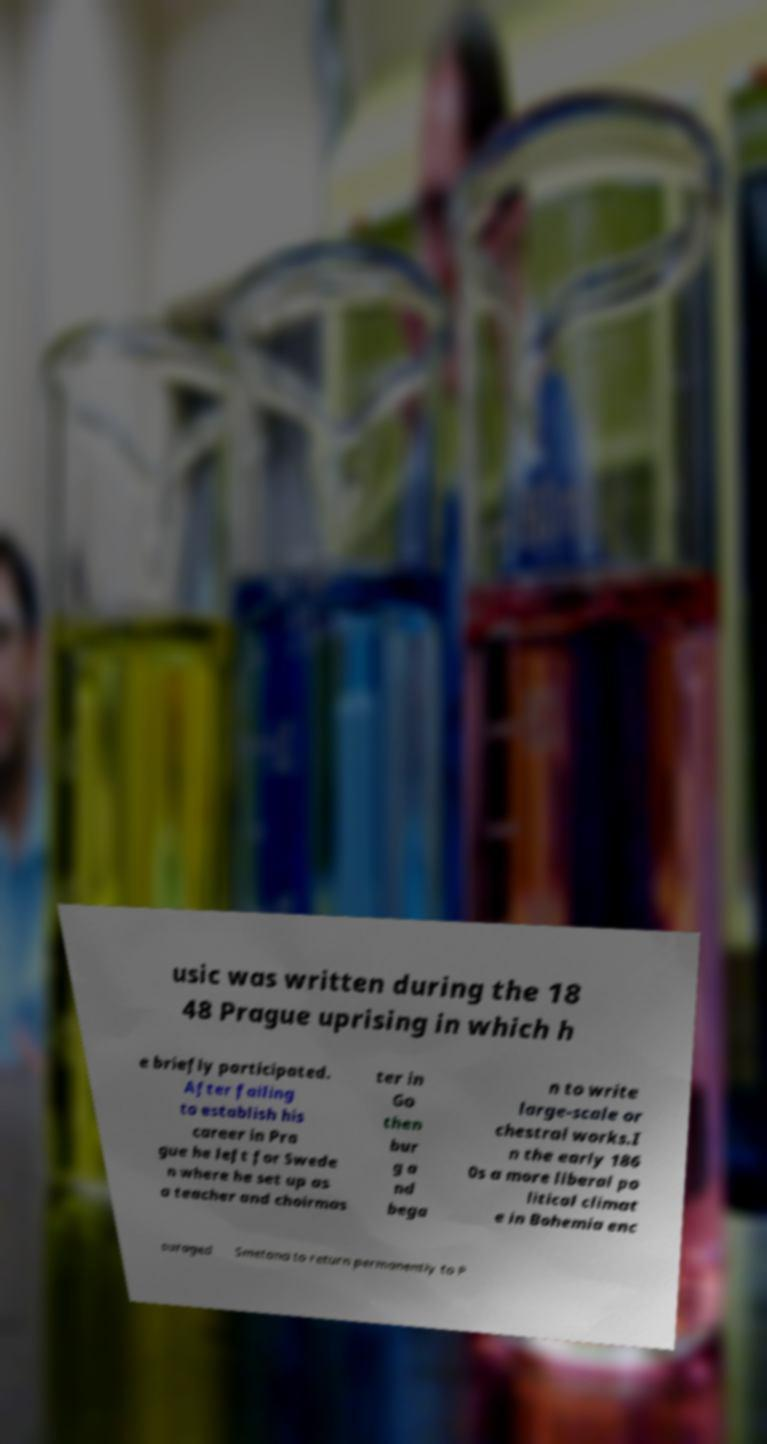For documentation purposes, I need the text within this image transcribed. Could you provide that? usic was written during the 18 48 Prague uprising in which h e briefly participated. After failing to establish his career in Pra gue he left for Swede n where he set up as a teacher and choirmas ter in Go then bur g a nd bega n to write large-scale or chestral works.I n the early 186 0s a more liberal po litical climat e in Bohemia enc ouraged Smetana to return permanently to P 